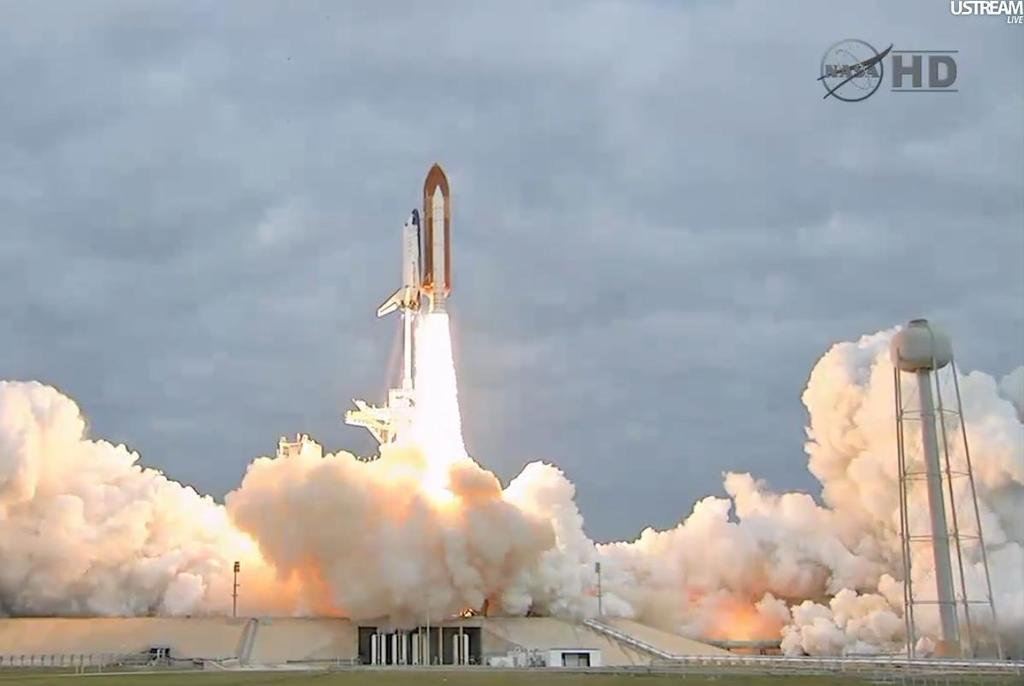What is the main subject in the center of the image? There is a rocket in the air in the center of the image. What can be seen at the bottom of the image? Fire and smoke are visible at the bottom of the image. What structures are present in the image? There is a tower and a building in the image. What is visible in the background of the image? Clouds and the sky are visible in the background of the image. What type of quiver is being used by the rocket in the image? There is no quiver present in the image; it features a rocket in the air. What type of plough is visible in the image? There is no plough present in the image; it features a rocket in the air. 